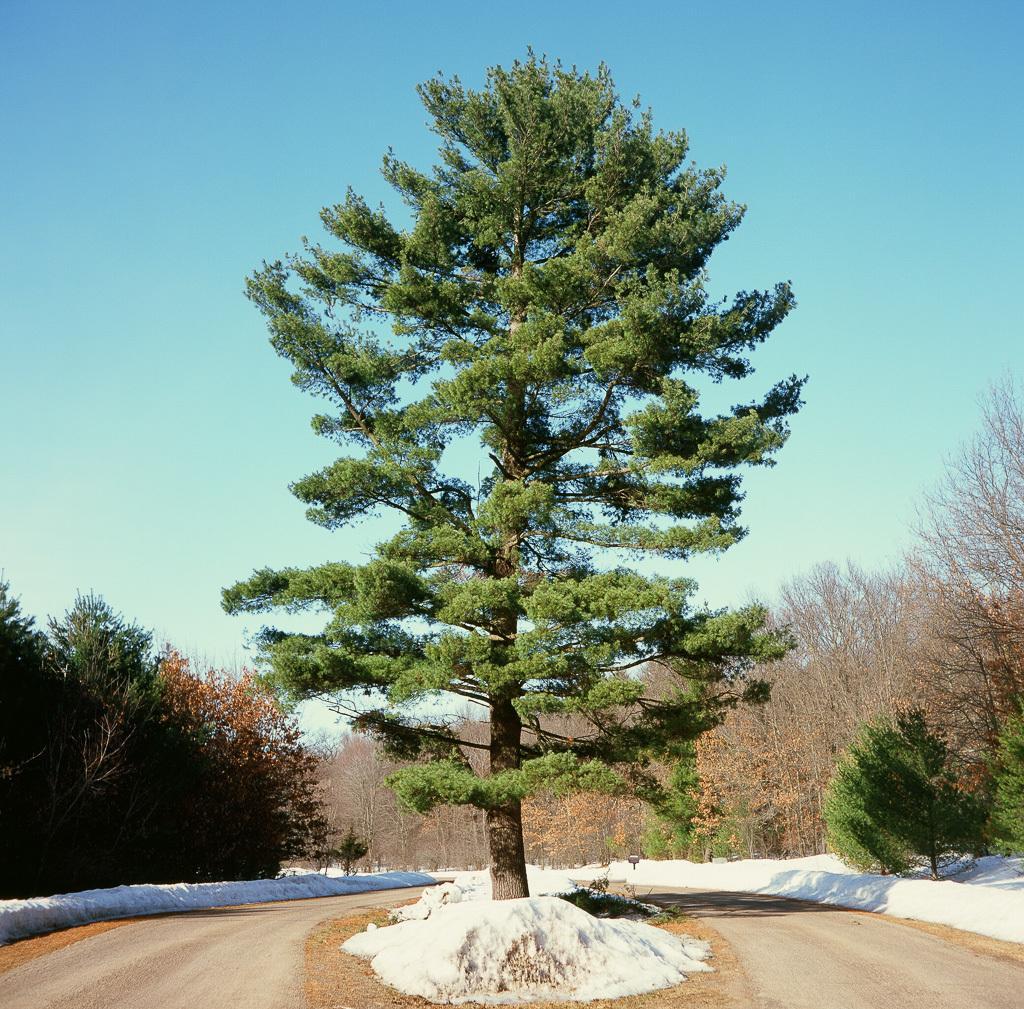Please provide a concise description of this image. In this image we can see the trees, road and also the sky. 